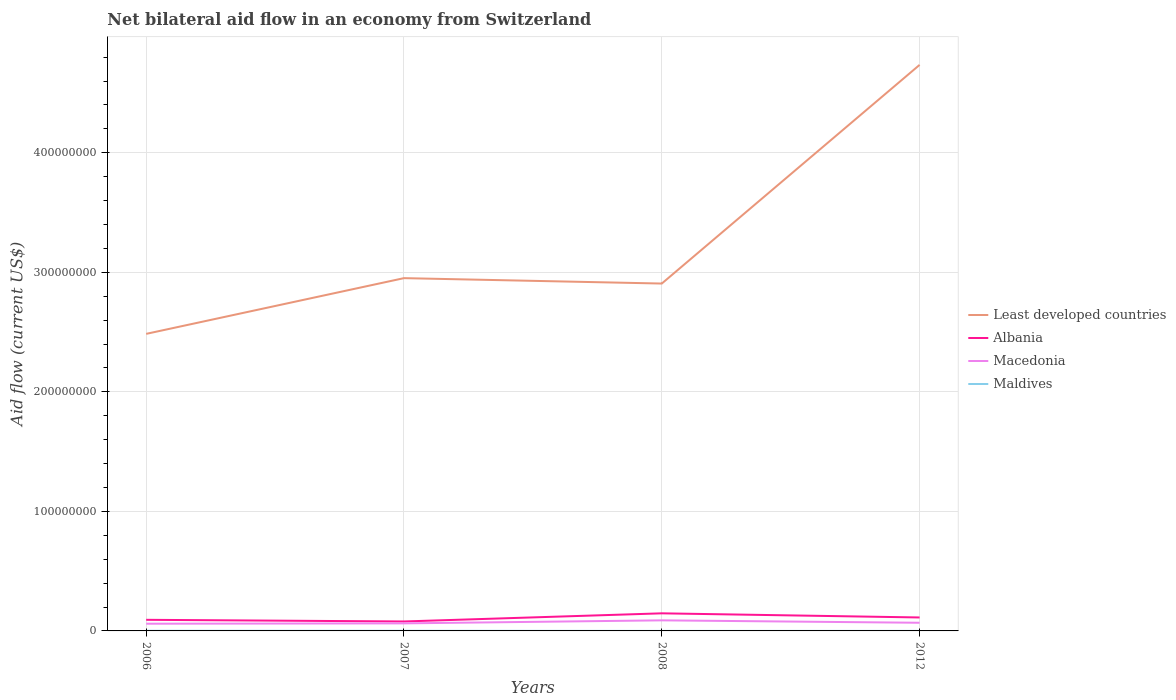Is the number of lines equal to the number of legend labels?
Ensure brevity in your answer.  Yes. Across all years, what is the maximum net bilateral aid flow in Least developed countries?
Provide a short and direct response. 2.49e+08. What is the total net bilateral aid flow in Maldives in the graph?
Your answer should be very brief. -2.00e+04. What is the difference between the highest and the second highest net bilateral aid flow in Least developed countries?
Provide a succinct answer. 2.25e+08. How many lines are there?
Provide a succinct answer. 4. What is the difference between two consecutive major ticks on the Y-axis?
Provide a short and direct response. 1.00e+08. Does the graph contain any zero values?
Your response must be concise. No. Does the graph contain grids?
Offer a very short reply. Yes. How many legend labels are there?
Your response must be concise. 4. What is the title of the graph?
Provide a succinct answer. Net bilateral aid flow in an economy from Switzerland. Does "Nepal" appear as one of the legend labels in the graph?
Your response must be concise. No. What is the label or title of the X-axis?
Provide a succinct answer. Years. What is the Aid flow (current US$) in Least developed countries in 2006?
Keep it short and to the point. 2.49e+08. What is the Aid flow (current US$) in Albania in 2006?
Offer a very short reply. 9.30e+06. What is the Aid flow (current US$) of Macedonia in 2006?
Offer a very short reply. 6.03e+06. What is the Aid flow (current US$) in Maldives in 2006?
Offer a terse response. 1.20e+05. What is the Aid flow (current US$) of Least developed countries in 2007?
Provide a succinct answer. 2.95e+08. What is the Aid flow (current US$) in Albania in 2007?
Your response must be concise. 7.91e+06. What is the Aid flow (current US$) in Macedonia in 2007?
Give a very brief answer. 6.31e+06. What is the Aid flow (current US$) in Maldives in 2007?
Give a very brief answer. 1.00e+05. What is the Aid flow (current US$) in Least developed countries in 2008?
Offer a very short reply. 2.91e+08. What is the Aid flow (current US$) of Albania in 2008?
Provide a succinct answer. 1.47e+07. What is the Aid flow (current US$) in Macedonia in 2008?
Offer a terse response. 8.85e+06. What is the Aid flow (current US$) in Least developed countries in 2012?
Your response must be concise. 4.74e+08. What is the Aid flow (current US$) of Albania in 2012?
Make the answer very short. 1.13e+07. What is the Aid flow (current US$) in Macedonia in 2012?
Offer a very short reply. 6.82e+06. What is the Aid flow (current US$) in Maldives in 2012?
Make the answer very short. 3.00e+04. Across all years, what is the maximum Aid flow (current US$) in Least developed countries?
Give a very brief answer. 4.74e+08. Across all years, what is the maximum Aid flow (current US$) of Albania?
Provide a succinct answer. 1.47e+07. Across all years, what is the maximum Aid flow (current US$) of Macedonia?
Ensure brevity in your answer.  8.85e+06. Across all years, what is the minimum Aid flow (current US$) in Least developed countries?
Ensure brevity in your answer.  2.49e+08. Across all years, what is the minimum Aid flow (current US$) of Albania?
Your answer should be compact. 7.91e+06. Across all years, what is the minimum Aid flow (current US$) of Macedonia?
Offer a very short reply. 6.03e+06. What is the total Aid flow (current US$) of Least developed countries in the graph?
Offer a very short reply. 1.31e+09. What is the total Aid flow (current US$) of Albania in the graph?
Provide a short and direct response. 4.32e+07. What is the total Aid flow (current US$) of Macedonia in the graph?
Ensure brevity in your answer.  2.80e+07. What is the total Aid flow (current US$) in Maldives in the graph?
Provide a short and direct response. 2.60e+05. What is the difference between the Aid flow (current US$) in Least developed countries in 2006 and that in 2007?
Give a very brief answer. -4.66e+07. What is the difference between the Aid flow (current US$) in Albania in 2006 and that in 2007?
Your answer should be very brief. 1.39e+06. What is the difference between the Aid flow (current US$) of Macedonia in 2006 and that in 2007?
Your response must be concise. -2.80e+05. What is the difference between the Aid flow (current US$) of Least developed countries in 2006 and that in 2008?
Provide a succinct answer. -4.21e+07. What is the difference between the Aid flow (current US$) of Albania in 2006 and that in 2008?
Offer a terse response. -5.42e+06. What is the difference between the Aid flow (current US$) in Macedonia in 2006 and that in 2008?
Make the answer very short. -2.82e+06. What is the difference between the Aid flow (current US$) of Maldives in 2006 and that in 2008?
Keep it short and to the point. 1.10e+05. What is the difference between the Aid flow (current US$) in Least developed countries in 2006 and that in 2012?
Provide a succinct answer. -2.25e+08. What is the difference between the Aid flow (current US$) of Albania in 2006 and that in 2012?
Keep it short and to the point. -1.96e+06. What is the difference between the Aid flow (current US$) in Macedonia in 2006 and that in 2012?
Ensure brevity in your answer.  -7.90e+05. What is the difference between the Aid flow (current US$) in Maldives in 2006 and that in 2012?
Ensure brevity in your answer.  9.00e+04. What is the difference between the Aid flow (current US$) in Least developed countries in 2007 and that in 2008?
Your response must be concise. 4.52e+06. What is the difference between the Aid flow (current US$) of Albania in 2007 and that in 2008?
Offer a terse response. -6.81e+06. What is the difference between the Aid flow (current US$) in Macedonia in 2007 and that in 2008?
Your answer should be compact. -2.54e+06. What is the difference between the Aid flow (current US$) of Least developed countries in 2007 and that in 2012?
Offer a very short reply. -1.78e+08. What is the difference between the Aid flow (current US$) of Albania in 2007 and that in 2012?
Your answer should be compact. -3.35e+06. What is the difference between the Aid flow (current US$) in Macedonia in 2007 and that in 2012?
Ensure brevity in your answer.  -5.10e+05. What is the difference between the Aid flow (current US$) in Least developed countries in 2008 and that in 2012?
Give a very brief answer. -1.83e+08. What is the difference between the Aid flow (current US$) of Albania in 2008 and that in 2012?
Offer a terse response. 3.46e+06. What is the difference between the Aid flow (current US$) in Macedonia in 2008 and that in 2012?
Provide a short and direct response. 2.03e+06. What is the difference between the Aid flow (current US$) of Least developed countries in 2006 and the Aid flow (current US$) of Albania in 2007?
Make the answer very short. 2.41e+08. What is the difference between the Aid flow (current US$) in Least developed countries in 2006 and the Aid flow (current US$) in Macedonia in 2007?
Make the answer very short. 2.42e+08. What is the difference between the Aid flow (current US$) in Least developed countries in 2006 and the Aid flow (current US$) in Maldives in 2007?
Offer a terse response. 2.48e+08. What is the difference between the Aid flow (current US$) of Albania in 2006 and the Aid flow (current US$) of Macedonia in 2007?
Make the answer very short. 2.99e+06. What is the difference between the Aid flow (current US$) of Albania in 2006 and the Aid flow (current US$) of Maldives in 2007?
Make the answer very short. 9.20e+06. What is the difference between the Aid flow (current US$) in Macedonia in 2006 and the Aid flow (current US$) in Maldives in 2007?
Keep it short and to the point. 5.93e+06. What is the difference between the Aid flow (current US$) of Least developed countries in 2006 and the Aid flow (current US$) of Albania in 2008?
Make the answer very short. 2.34e+08. What is the difference between the Aid flow (current US$) of Least developed countries in 2006 and the Aid flow (current US$) of Macedonia in 2008?
Provide a short and direct response. 2.40e+08. What is the difference between the Aid flow (current US$) in Least developed countries in 2006 and the Aid flow (current US$) in Maldives in 2008?
Offer a very short reply. 2.49e+08. What is the difference between the Aid flow (current US$) in Albania in 2006 and the Aid flow (current US$) in Maldives in 2008?
Your answer should be compact. 9.29e+06. What is the difference between the Aid flow (current US$) of Macedonia in 2006 and the Aid flow (current US$) of Maldives in 2008?
Provide a succinct answer. 6.02e+06. What is the difference between the Aid flow (current US$) in Least developed countries in 2006 and the Aid flow (current US$) in Albania in 2012?
Your response must be concise. 2.37e+08. What is the difference between the Aid flow (current US$) of Least developed countries in 2006 and the Aid flow (current US$) of Macedonia in 2012?
Your response must be concise. 2.42e+08. What is the difference between the Aid flow (current US$) in Least developed countries in 2006 and the Aid flow (current US$) in Maldives in 2012?
Make the answer very short. 2.48e+08. What is the difference between the Aid flow (current US$) in Albania in 2006 and the Aid flow (current US$) in Macedonia in 2012?
Your answer should be very brief. 2.48e+06. What is the difference between the Aid flow (current US$) in Albania in 2006 and the Aid flow (current US$) in Maldives in 2012?
Provide a succinct answer. 9.27e+06. What is the difference between the Aid flow (current US$) of Least developed countries in 2007 and the Aid flow (current US$) of Albania in 2008?
Provide a succinct answer. 2.80e+08. What is the difference between the Aid flow (current US$) of Least developed countries in 2007 and the Aid flow (current US$) of Macedonia in 2008?
Your answer should be compact. 2.86e+08. What is the difference between the Aid flow (current US$) in Least developed countries in 2007 and the Aid flow (current US$) in Maldives in 2008?
Provide a succinct answer. 2.95e+08. What is the difference between the Aid flow (current US$) in Albania in 2007 and the Aid flow (current US$) in Macedonia in 2008?
Make the answer very short. -9.40e+05. What is the difference between the Aid flow (current US$) of Albania in 2007 and the Aid flow (current US$) of Maldives in 2008?
Offer a terse response. 7.90e+06. What is the difference between the Aid flow (current US$) in Macedonia in 2007 and the Aid flow (current US$) in Maldives in 2008?
Your answer should be compact. 6.30e+06. What is the difference between the Aid flow (current US$) of Least developed countries in 2007 and the Aid flow (current US$) of Albania in 2012?
Your answer should be compact. 2.84e+08. What is the difference between the Aid flow (current US$) in Least developed countries in 2007 and the Aid flow (current US$) in Macedonia in 2012?
Offer a terse response. 2.88e+08. What is the difference between the Aid flow (current US$) in Least developed countries in 2007 and the Aid flow (current US$) in Maldives in 2012?
Offer a very short reply. 2.95e+08. What is the difference between the Aid flow (current US$) of Albania in 2007 and the Aid flow (current US$) of Macedonia in 2012?
Provide a succinct answer. 1.09e+06. What is the difference between the Aid flow (current US$) of Albania in 2007 and the Aid flow (current US$) of Maldives in 2012?
Keep it short and to the point. 7.88e+06. What is the difference between the Aid flow (current US$) in Macedonia in 2007 and the Aid flow (current US$) in Maldives in 2012?
Give a very brief answer. 6.28e+06. What is the difference between the Aid flow (current US$) in Least developed countries in 2008 and the Aid flow (current US$) in Albania in 2012?
Offer a very short reply. 2.79e+08. What is the difference between the Aid flow (current US$) of Least developed countries in 2008 and the Aid flow (current US$) of Macedonia in 2012?
Make the answer very short. 2.84e+08. What is the difference between the Aid flow (current US$) in Least developed countries in 2008 and the Aid flow (current US$) in Maldives in 2012?
Make the answer very short. 2.91e+08. What is the difference between the Aid flow (current US$) in Albania in 2008 and the Aid flow (current US$) in Macedonia in 2012?
Offer a very short reply. 7.90e+06. What is the difference between the Aid flow (current US$) of Albania in 2008 and the Aid flow (current US$) of Maldives in 2012?
Offer a terse response. 1.47e+07. What is the difference between the Aid flow (current US$) in Macedonia in 2008 and the Aid flow (current US$) in Maldives in 2012?
Offer a terse response. 8.82e+06. What is the average Aid flow (current US$) in Least developed countries per year?
Keep it short and to the point. 3.27e+08. What is the average Aid flow (current US$) in Albania per year?
Your response must be concise. 1.08e+07. What is the average Aid flow (current US$) of Macedonia per year?
Your response must be concise. 7.00e+06. What is the average Aid flow (current US$) of Maldives per year?
Provide a short and direct response. 6.50e+04. In the year 2006, what is the difference between the Aid flow (current US$) of Least developed countries and Aid flow (current US$) of Albania?
Make the answer very short. 2.39e+08. In the year 2006, what is the difference between the Aid flow (current US$) of Least developed countries and Aid flow (current US$) of Macedonia?
Offer a very short reply. 2.42e+08. In the year 2006, what is the difference between the Aid flow (current US$) of Least developed countries and Aid flow (current US$) of Maldives?
Give a very brief answer. 2.48e+08. In the year 2006, what is the difference between the Aid flow (current US$) in Albania and Aid flow (current US$) in Macedonia?
Provide a short and direct response. 3.27e+06. In the year 2006, what is the difference between the Aid flow (current US$) of Albania and Aid flow (current US$) of Maldives?
Keep it short and to the point. 9.18e+06. In the year 2006, what is the difference between the Aid flow (current US$) in Macedonia and Aid flow (current US$) in Maldives?
Give a very brief answer. 5.91e+06. In the year 2007, what is the difference between the Aid flow (current US$) of Least developed countries and Aid flow (current US$) of Albania?
Make the answer very short. 2.87e+08. In the year 2007, what is the difference between the Aid flow (current US$) of Least developed countries and Aid flow (current US$) of Macedonia?
Give a very brief answer. 2.89e+08. In the year 2007, what is the difference between the Aid flow (current US$) of Least developed countries and Aid flow (current US$) of Maldives?
Your answer should be very brief. 2.95e+08. In the year 2007, what is the difference between the Aid flow (current US$) of Albania and Aid flow (current US$) of Macedonia?
Provide a short and direct response. 1.60e+06. In the year 2007, what is the difference between the Aid flow (current US$) of Albania and Aid flow (current US$) of Maldives?
Your answer should be compact. 7.81e+06. In the year 2007, what is the difference between the Aid flow (current US$) of Macedonia and Aid flow (current US$) of Maldives?
Your answer should be compact. 6.21e+06. In the year 2008, what is the difference between the Aid flow (current US$) in Least developed countries and Aid flow (current US$) in Albania?
Your response must be concise. 2.76e+08. In the year 2008, what is the difference between the Aid flow (current US$) in Least developed countries and Aid flow (current US$) in Macedonia?
Give a very brief answer. 2.82e+08. In the year 2008, what is the difference between the Aid flow (current US$) in Least developed countries and Aid flow (current US$) in Maldives?
Ensure brevity in your answer.  2.91e+08. In the year 2008, what is the difference between the Aid flow (current US$) in Albania and Aid flow (current US$) in Macedonia?
Offer a very short reply. 5.87e+06. In the year 2008, what is the difference between the Aid flow (current US$) of Albania and Aid flow (current US$) of Maldives?
Ensure brevity in your answer.  1.47e+07. In the year 2008, what is the difference between the Aid flow (current US$) of Macedonia and Aid flow (current US$) of Maldives?
Give a very brief answer. 8.84e+06. In the year 2012, what is the difference between the Aid flow (current US$) in Least developed countries and Aid flow (current US$) in Albania?
Your answer should be very brief. 4.62e+08. In the year 2012, what is the difference between the Aid flow (current US$) of Least developed countries and Aid flow (current US$) of Macedonia?
Your response must be concise. 4.67e+08. In the year 2012, what is the difference between the Aid flow (current US$) of Least developed countries and Aid flow (current US$) of Maldives?
Make the answer very short. 4.74e+08. In the year 2012, what is the difference between the Aid flow (current US$) in Albania and Aid flow (current US$) in Macedonia?
Give a very brief answer. 4.44e+06. In the year 2012, what is the difference between the Aid flow (current US$) in Albania and Aid flow (current US$) in Maldives?
Ensure brevity in your answer.  1.12e+07. In the year 2012, what is the difference between the Aid flow (current US$) of Macedonia and Aid flow (current US$) of Maldives?
Keep it short and to the point. 6.79e+06. What is the ratio of the Aid flow (current US$) of Least developed countries in 2006 to that in 2007?
Give a very brief answer. 0.84. What is the ratio of the Aid flow (current US$) in Albania in 2006 to that in 2007?
Your answer should be very brief. 1.18. What is the ratio of the Aid flow (current US$) in Macedonia in 2006 to that in 2007?
Ensure brevity in your answer.  0.96. What is the ratio of the Aid flow (current US$) in Least developed countries in 2006 to that in 2008?
Make the answer very short. 0.86. What is the ratio of the Aid flow (current US$) of Albania in 2006 to that in 2008?
Offer a very short reply. 0.63. What is the ratio of the Aid flow (current US$) in Macedonia in 2006 to that in 2008?
Your response must be concise. 0.68. What is the ratio of the Aid flow (current US$) in Maldives in 2006 to that in 2008?
Give a very brief answer. 12. What is the ratio of the Aid flow (current US$) in Least developed countries in 2006 to that in 2012?
Keep it short and to the point. 0.52. What is the ratio of the Aid flow (current US$) in Albania in 2006 to that in 2012?
Offer a terse response. 0.83. What is the ratio of the Aid flow (current US$) in Macedonia in 2006 to that in 2012?
Your answer should be very brief. 0.88. What is the ratio of the Aid flow (current US$) in Maldives in 2006 to that in 2012?
Keep it short and to the point. 4. What is the ratio of the Aid flow (current US$) of Least developed countries in 2007 to that in 2008?
Provide a short and direct response. 1.02. What is the ratio of the Aid flow (current US$) in Albania in 2007 to that in 2008?
Make the answer very short. 0.54. What is the ratio of the Aid flow (current US$) in Macedonia in 2007 to that in 2008?
Your answer should be very brief. 0.71. What is the ratio of the Aid flow (current US$) of Maldives in 2007 to that in 2008?
Your answer should be compact. 10. What is the ratio of the Aid flow (current US$) of Least developed countries in 2007 to that in 2012?
Give a very brief answer. 0.62. What is the ratio of the Aid flow (current US$) in Albania in 2007 to that in 2012?
Your answer should be very brief. 0.7. What is the ratio of the Aid flow (current US$) of Macedonia in 2007 to that in 2012?
Ensure brevity in your answer.  0.93. What is the ratio of the Aid flow (current US$) of Maldives in 2007 to that in 2012?
Make the answer very short. 3.33. What is the ratio of the Aid flow (current US$) in Least developed countries in 2008 to that in 2012?
Your response must be concise. 0.61. What is the ratio of the Aid flow (current US$) in Albania in 2008 to that in 2012?
Provide a succinct answer. 1.31. What is the ratio of the Aid flow (current US$) of Macedonia in 2008 to that in 2012?
Provide a short and direct response. 1.3. What is the ratio of the Aid flow (current US$) in Maldives in 2008 to that in 2012?
Offer a very short reply. 0.33. What is the difference between the highest and the second highest Aid flow (current US$) in Least developed countries?
Offer a very short reply. 1.78e+08. What is the difference between the highest and the second highest Aid flow (current US$) of Albania?
Your response must be concise. 3.46e+06. What is the difference between the highest and the second highest Aid flow (current US$) of Macedonia?
Provide a short and direct response. 2.03e+06. What is the difference between the highest and the lowest Aid flow (current US$) in Least developed countries?
Offer a very short reply. 2.25e+08. What is the difference between the highest and the lowest Aid flow (current US$) of Albania?
Ensure brevity in your answer.  6.81e+06. What is the difference between the highest and the lowest Aid flow (current US$) of Macedonia?
Provide a succinct answer. 2.82e+06. 